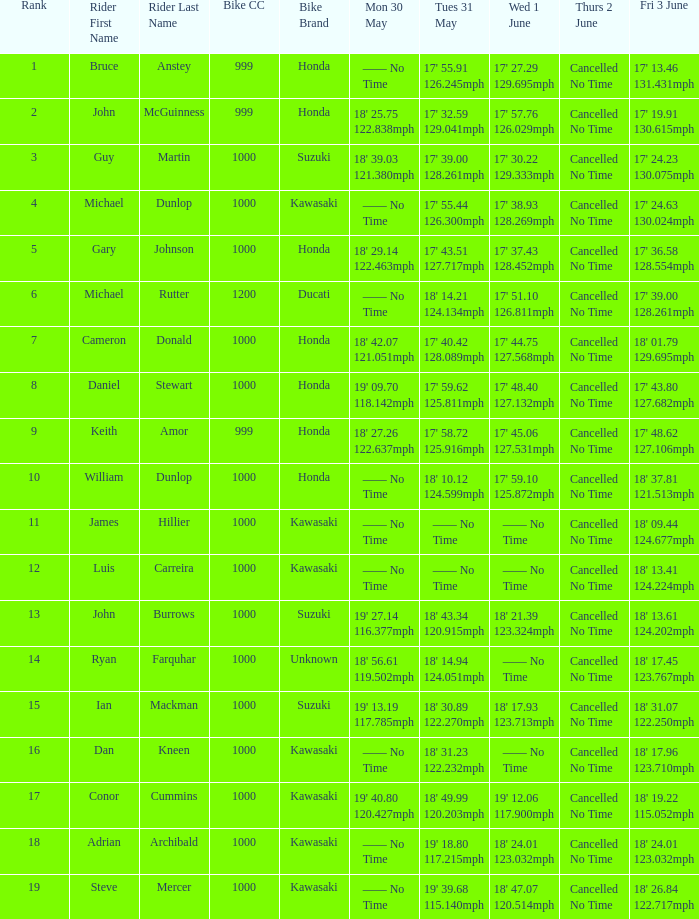Can you parse all the data within this table? {'header': ['Rank', 'Rider First Name', 'Rider Last Name', 'Bike CC', 'Bike Brand', 'Mon 30 May', 'Tues 31 May', 'Wed 1 June', 'Thurs 2 June', 'Fri 3 June'], 'rows': [['1', 'Bruce', 'Anstey', '999', 'Honda', '—— No Time', "17' 55.91 126.245mph", "17' 27.29 129.695mph", 'Cancelled No Time', "17' 13.46 131.431mph"], ['2', 'John', 'McGuinness', '999', 'Honda', "18' 25.75 122.838mph", "17' 32.59 129.041mph", "17' 57.76 126.029mph", 'Cancelled No Time', "17' 19.91 130.615mph"], ['3', 'Guy', 'Martin', '1000', 'Suzuki', "18' 39.03 121.380mph", "17' 39.00 128.261mph", "17' 30.22 129.333mph", 'Cancelled No Time', "17' 24.23 130.075mph"], ['4', 'Michael', 'Dunlop', '1000', 'Kawasaki', '—— No Time', "17' 55.44 126.300mph", "17' 38.93 128.269mph", 'Cancelled No Time', "17' 24.63 130.024mph"], ['5', 'Gary', 'Johnson', '1000', 'Honda', "18' 29.14 122.463mph", "17' 43.51 127.717mph", "17' 37.43 128.452mph", 'Cancelled No Time', "17' 36.58 128.554mph"], ['6', 'Michael', 'Rutter', '1200', 'Ducati', '—— No Time', "18' 14.21 124.134mph", "17' 51.10 126.811mph", 'Cancelled No Time', "17' 39.00 128.261mph"], ['7', 'Cameron', 'Donald', '1000', 'Honda', "18' 42.07 121.051mph", "17' 40.42 128.089mph", "17' 44.75 127.568mph", 'Cancelled No Time', "18' 01.79 129.695mph"], ['8', 'Daniel', 'Stewart', '1000', 'Honda', "19' 09.70 118.142mph", "17' 59.62 125.811mph", "17' 48.40 127.132mph", 'Cancelled No Time', "17' 43.80 127.682mph"], ['9', 'Keith', 'Amor', '999', 'Honda', "18' 27.26 122.637mph", "17' 58.72 125.916mph", "17' 45.06 127.531mph", 'Cancelled No Time', "17' 48.62 127.106mph"], ['10', 'William', 'Dunlop', '1000', 'Honda', '—— No Time', "18' 10.12 124.599mph", "17' 59.10 125.872mph", 'Cancelled No Time', "18' 37.81 121.513mph"], ['11', 'James', 'Hillier', '1000', 'Kawasaki', '—— No Time', '—— No Time', '—— No Time', 'Cancelled No Time', "18' 09.44 124.677mph"], ['12', 'Luis', 'Carreira', '1000', 'Kawasaki', '—— No Time', '—— No Time', '—— No Time', 'Cancelled No Time', "18' 13.41 124.224mph"], ['13', 'John', 'Burrows', '1000', 'Suzuki', "19' 27.14 116.377mph", "18' 43.34 120.915mph", "18' 21.39 123.324mph", 'Cancelled No Time', "18' 13.61 124.202mph"], ['14', 'Ryan', 'Farquhar', '1000', 'Unknown', "18' 56.61 119.502mph", "18' 14.94 124.051mph", '—— No Time', 'Cancelled No Time', "18' 17.45 123.767mph"], ['15', 'Ian', 'Mackman', '1000', 'Suzuki', "19' 13.19 117.785mph", "18' 30.89 122.270mph", "18' 17.93 123.713mph", 'Cancelled No Time', "18' 31.07 122.250mph"], ['16', 'Dan', 'Kneen', '1000', 'Kawasaki', '—— No Time', "18' 31.23 122.232mph", '—— No Time', 'Cancelled No Time', "18' 17.96 123.710mph"], ['17', 'Conor', 'Cummins', '1000', 'Kawasaki', "19' 40.80 120.427mph", "18' 49.99 120.203mph", "19' 12.06 117.900mph", 'Cancelled No Time', "18' 19.22 115.052mph"], ['18', 'Adrian', 'Archibald', '1000', 'Kawasaki', '—— No Time', "19' 18.80 117.215mph", "18' 24.01 123.032mph", 'Cancelled No Time', "18' 24.01 123.032mph"], ['19', 'Steve', 'Mercer', '1000', 'Kawasaki', '—— No Time', "19' 39.68 115.140mph", "18' 47.07 120.514mph", 'Cancelled No Time', "18' 26.84 122.717mph"]]} What is the Fri 3 June time for the rider whose Tues 31 May time was 19' 18.80 117.215mph? 18' 24.01 123.032mph. 